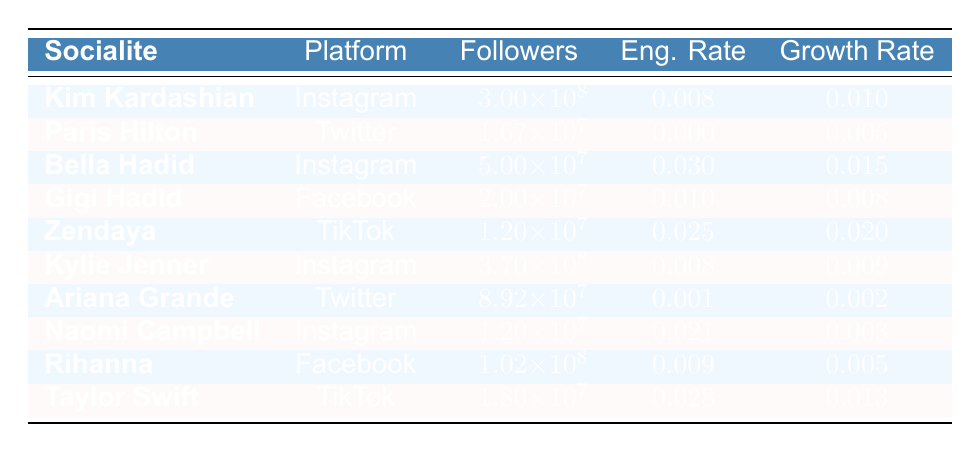What is the engagement rate of Kim Kardashian on Instagram? According to the table, Kim Kardashian has an engagement rate of 0.008.
Answer: 0.008 Which socialite has the highest number of followers? The table indicates that Kim Kardashian has the most followers at 300,000,000.
Answer: Kim Kardashian How many followers does Bella Hadid have compared to Gigi Hadid? Bella Hadid has 50,000,000 followers while Gigi Hadid has 20,000,000. The difference is 50,000,000 - 20,000,000 = 30,000,000.
Answer: 30,000,000 Is Ariana Grande's engagement rate higher than that of Naomi Campbell? Ariana Grande's engagement rate is 0.0009, while Naomi Campbell's is 0.021. Since 0.0009 < 0.021, the statement is false.
Answer: No Which platforms are represented for socialites with engagement rates over 0.02? Bella Hadid (Instagram), Zendaya (TikTok), and Taylor Swift (TikTok) have engagement rates over 0.02. This can be seen by comparing their respective engagement rates in the table.
Answer: Instagram, TikTok What is the average engagement rate of the socialites listed in the table? The engagement rates are 0.008, 0.0003, 0.03, 0.01, 0.025, 0.0081, 0.0009, 0.021, 0.0088, and 0.028. Adding these gives 0.1123, and dividing by 10 (the number of socialites) gives an average of 0.01123, which rounds to 0.011.
Answer: 0.011 Can you find a socialite whose follower growth rate is over 0.015? Bella Hadid has a follower growth rate of 0.015, which is not over 0.015. However, Zendaya has 0.02, which is over 0.015.
Answer: Yes, Zendaya What is the total number of followers for all socialites on Instagram? The Instagram socialites are Kim Kardashian (300,000,000), Bella Hadid (50,000,000), and Kylie Jenner (370,000,000). Adding these gives 300,000,000 + 50,000,000 + 370,000,000 = 720,000,000.
Answer: 720,000,000 Which socialite has the lowest engagement rate? Paris Hilton has the lowest engagement rate at 0.0003, as seen in the table.
Answer: Paris Hilton If we compare the average likes of socialites on TikTok, who has the highest? Zendaya has 300,000 likes, and Taylor Swift has 500,000 likes on TikTok. Thus, Taylor Swift has the highest average likes on that platform.
Answer: Taylor Swift 